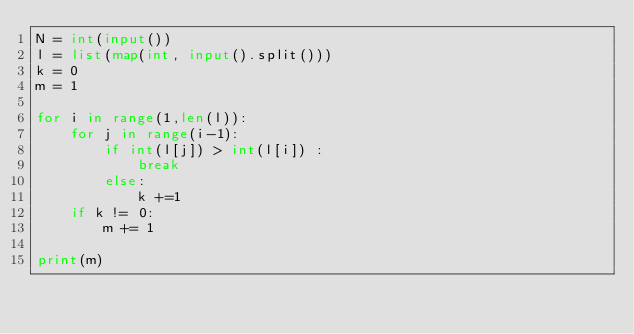Convert code to text. <code><loc_0><loc_0><loc_500><loc_500><_Python_>N = int(input())
l = list(map(int, input().split()))
k = 0
m = 1

for i in range(1,len(l)):
    for j in range(i-1):
        if int(l[j]) > int(l[i]) :
            break
        else:
            k +=1
    if k != 0:
        m += 1
        
print(m)</code> 